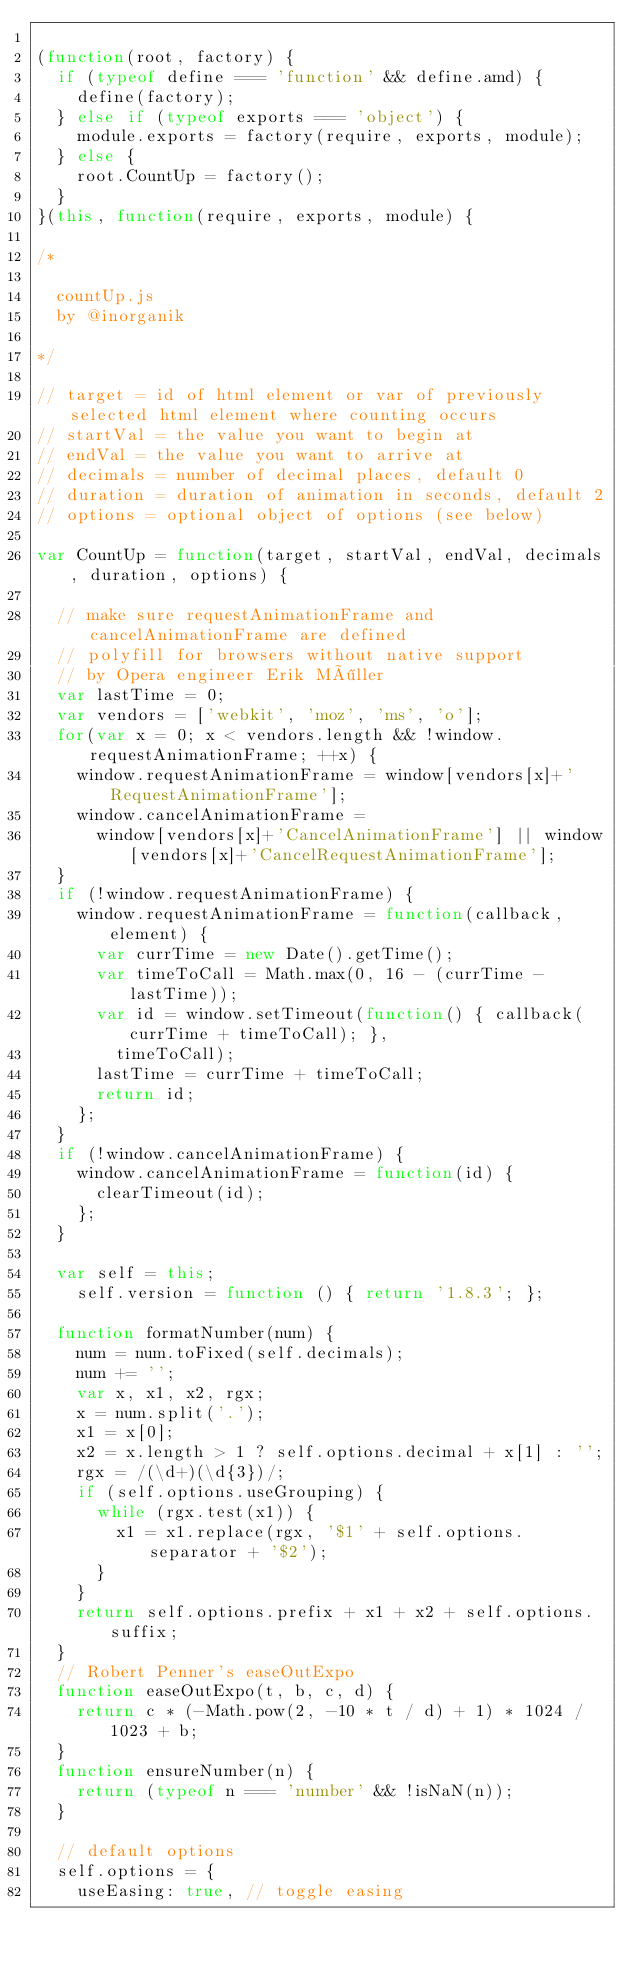Convert code to text. <code><loc_0><loc_0><loc_500><loc_500><_JavaScript_>
(function(root, factory) {
  if (typeof define === 'function' && define.amd) {
    define(factory);
  } else if (typeof exports === 'object') {
    module.exports = factory(require, exports, module);
  } else {
    root.CountUp = factory();
  }
}(this, function(require, exports, module) {

/*

	countUp.js
	by @inorganik

*/

// target = id of html element or var of previously selected html element where counting occurs
// startVal = the value you want to begin at
// endVal = the value you want to arrive at
// decimals = number of decimal places, default 0
// duration = duration of animation in seconds, default 2
// options = optional object of options (see below)

var CountUp = function(target, startVal, endVal, decimals, duration, options) {

	// make sure requestAnimationFrame and cancelAnimationFrame are defined
	// polyfill for browsers without native support
	// by Opera engineer Erik Möller
	var lastTime = 0;
	var vendors = ['webkit', 'moz', 'ms', 'o'];
	for(var x = 0; x < vendors.length && !window.requestAnimationFrame; ++x) {
		window.requestAnimationFrame = window[vendors[x]+'RequestAnimationFrame'];
		window.cancelAnimationFrame =
		  window[vendors[x]+'CancelAnimationFrame'] || window[vendors[x]+'CancelRequestAnimationFrame'];
	}
	if (!window.requestAnimationFrame) {
		window.requestAnimationFrame = function(callback, element) {
			var currTime = new Date().getTime();
			var timeToCall = Math.max(0, 16 - (currTime - lastTime));
			var id = window.setTimeout(function() { callback(currTime + timeToCall); },
			  timeToCall);
			lastTime = currTime + timeToCall;
			return id;
		};
	}
	if (!window.cancelAnimationFrame) {
		window.cancelAnimationFrame = function(id) {
			clearTimeout(id);
		};
	}

	var self = this;
    self.version = function () { return '1.8.3'; };

	function formatNumber(num) {
		num = num.toFixed(self.decimals);
		num += '';
		var x, x1, x2, rgx;
		x = num.split('.');
		x1 = x[0];
		x2 = x.length > 1 ? self.options.decimal + x[1] : '';
		rgx = /(\d+)(\d{3})/;
		if (self.options.useGrouping) {
			while (rgx.test(x1)) {
				x1 = x1.replace(rgx, '$1' + self.options.separator + '$2');
			}
		}
		return self.options.prefix + x1 + x2 + self.options.suffix;
	}
	// Robert Penner's easeOutExpo
	function easeOutExpo(t, b, c, d) {
		return c * (-Math.pow(2, -10 * t / d) + 1) * 1024 / 1023 + b;
	}
	function ensureNumber(n) {
		return (typeof n === 'number' && !isNaN(n));
	}
	
	// default options
	self.options = {
		useEasing: true, // toggle easing</code> 